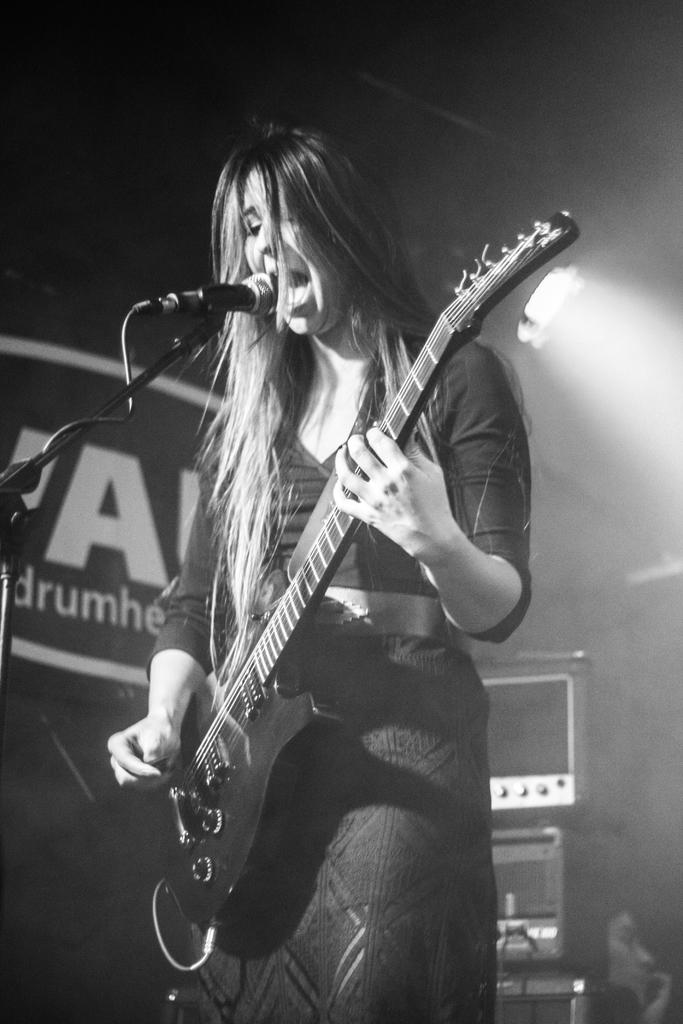What is the main subject of the image? The main subject of the image is a woman. What is the woman doing in the image? The woman is standing, playing a guitar, and singing into a microphone. What can be seen in the background of the image? There is a speaker and a light in the background of the image. What type of produce is the woman using to crush the police officer in the image? There is no produce, police officer, or crushing action present in the image. 